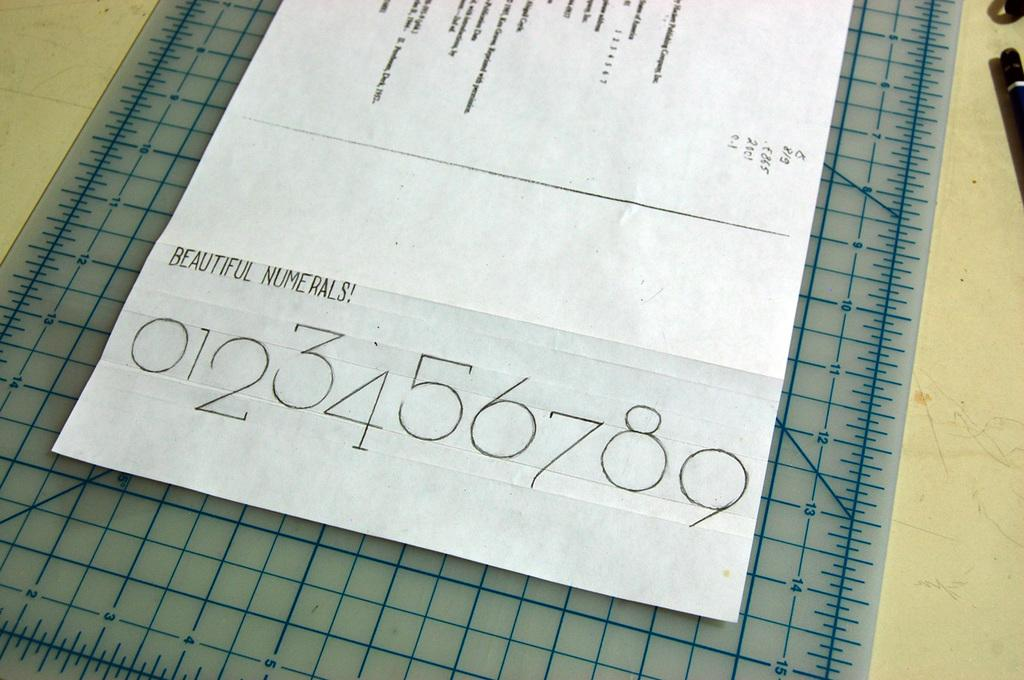<image>
Share a concise interpretation of the image provided. A piece of paper on top a measuring grid that says Beautiful Numerals on it. 